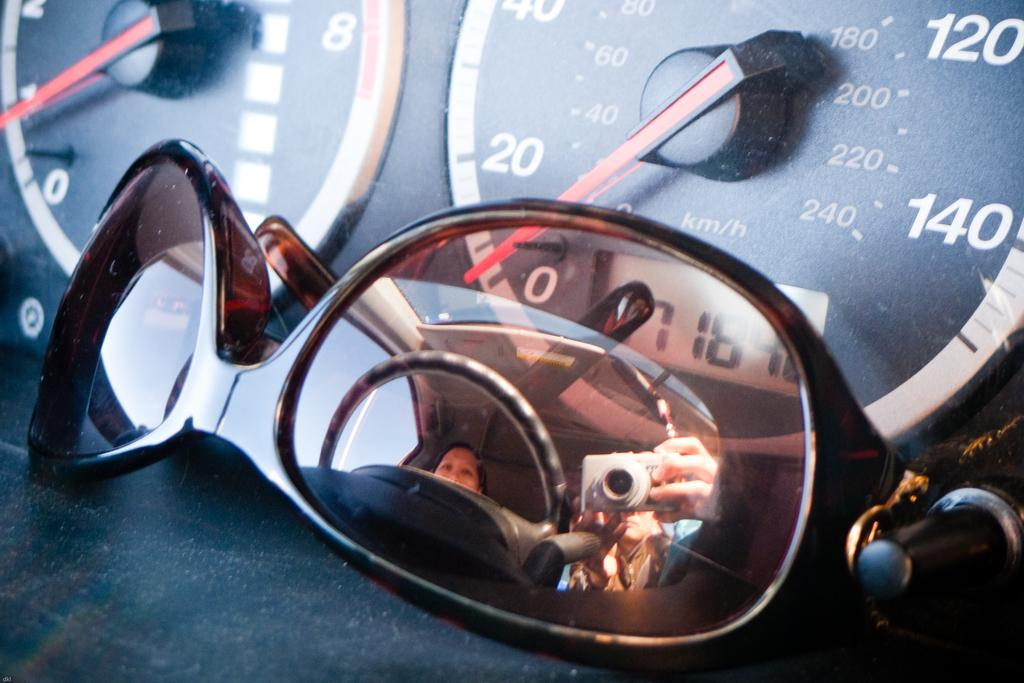What object is present in the image that is commonly used for eye protection? There are sunglasses in the image. What are the sunglasses placed in front of? The sunglasses are in front of speedometers. Can you describe any additional details about the sunglasses? Yes, there are reflections of persons on the sunglasses. What type of drug can be seen in the image? There is no drug present in the image; it features sunglasses in front of speedometers with reflections of persons. What kind of stick is being used to stir the sunglasses in the image? There is no stick or stirring action involved with the sunglasses in the image. 